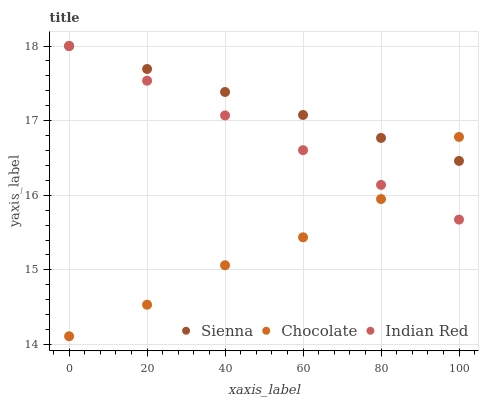Does Chocolate have the minimum area under the curve?
Answer yes or no. Yes. Does Sienna have the maximum area under the curve?
Answer yes or no. Yes. Does Indian Red have the minimum area under the curve?
Answer yes or no. No. Does Indian Red have the maximum area under the curve?
Answer yes or no. No. Is Indian Red the smoothest?
Answer yes or no. Yes. Is Chocolate the roughest?
Answer yes or no. Yes. Is Chocolate the smoothest?
Answer yes or no. No. Is Indian Red the roughest?
Answer yes or no. No. Does Chocolate have the lowest value?
Answer yes or no. Yes. Does Indian Red have the lowest value?
Answer yes or no. No. Does Indian Red have the highest value?
Answer yes or no. Yes. Does Chocolate have the highest value?
Answer yes or no. No. Does Chocolate intersect Indian Red?
Answer yes or no. Yes. Is Chocolate less than Indian Red?
Answer yes or no. No. Is Chocolate greater than Indian Red?
Answer yes or no. No. 